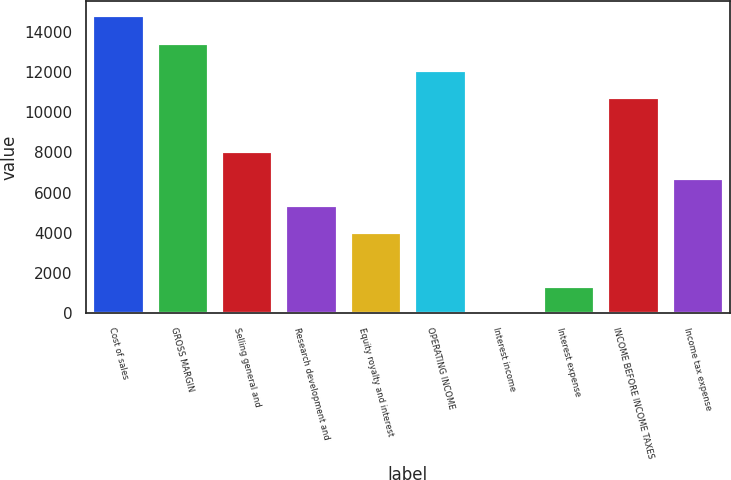Convert chart to OTSL. <chart><loc_0><loc_0><loc_500><loc_500><bar_chart><fcel>Cost of sales<fcel>GROSS MARGIN<fcel>Selling general and<fcel>Research development and<fcel>Equity royalty and interest<fcel>OPERATING INCOME<fcel>Interest income<fcel>Interest expense<fcel>INCOME BEFORE INCOME TAXES<fcel>Income tax expense<nl><fcel>14801.5<fcel>13459<fcel>8089<fcel>5404<fcel>4061.5<fcel>12116.5<fcel>34<fcel>1376.5<fcel>10774<fcel>6746.5<nl></chart> 